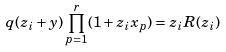<formula> <loc_0><loc_0><loc_500><loc_500>q ( z _ { i } + y ) \prod _ { p = 1 } ^ { r } ( 1 + z _ { i } x _ { p } ) = z _ { i } R ( z _ { i } )</formula> 